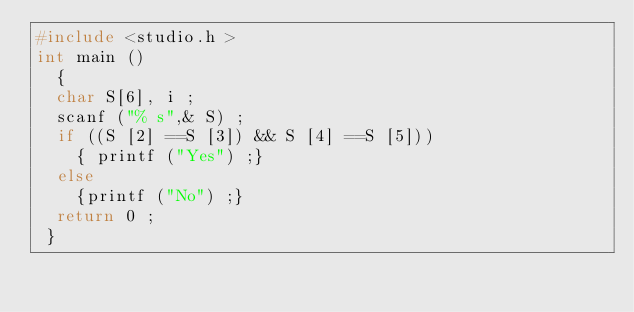Convert code to text. <code><loc_0><loc_0><loc_500><loc_500><_C_>#include <studio.h >
int main () 
  {
  char S[6], i ;
  scanf ("% s",& S) ;
  if ((S [2] ==S [3]) && S [4] ==S [5])) 
    { printf ("Yes") ;} 
  else 
    {printf ("No") ;} 
  return 0 ;
 } </code> 